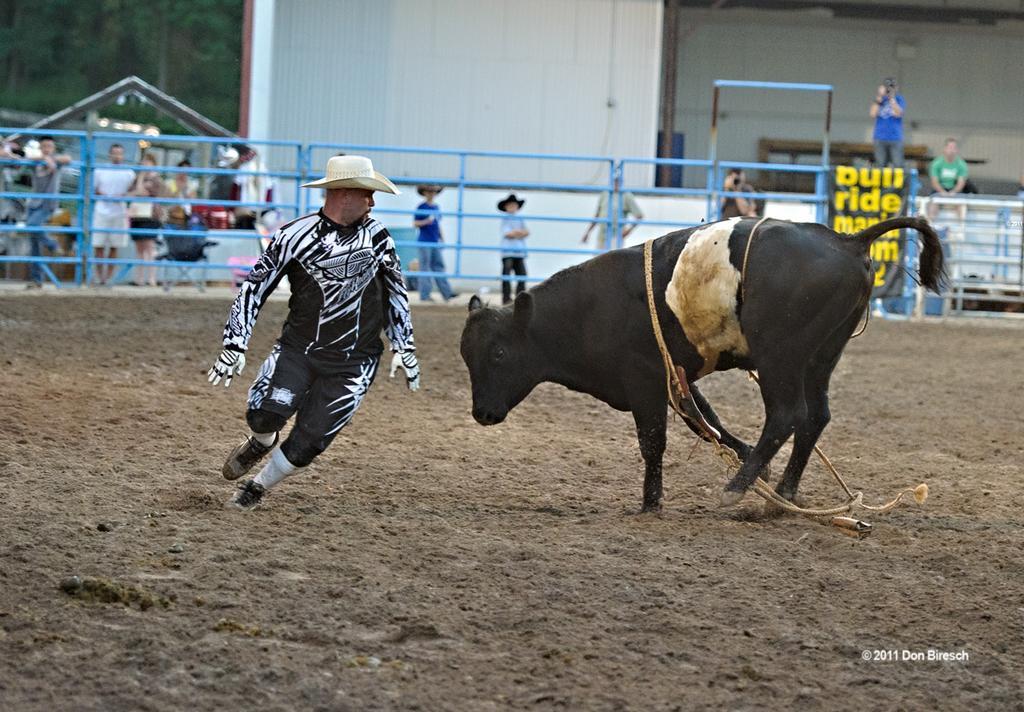Describe this image in one or two sentences. In this given image, I can see small garden which is build with an boundary iron metals and i can see a buffalo and a person inside the ground, Outside the boundary wall a couple of people capturing the moments sitting and standing. 